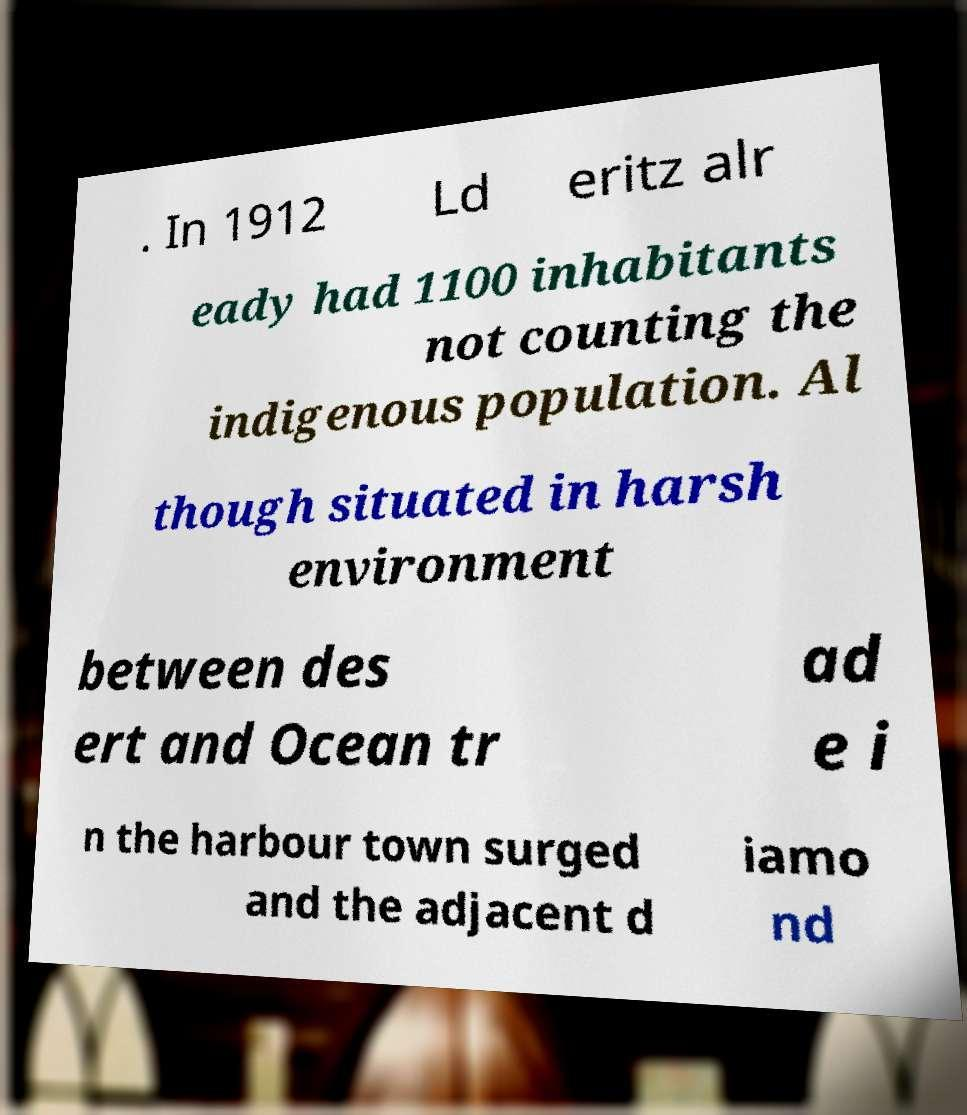Can you accurately transcribe the text from the provided image for me? . In 1912 Ld eritz alr eady had 1100 inhabitants not counting the indigenous population. Al though situated in harsh environment between des ert and Ocean tr ad e i n the harbour town surged and the adjacent d iamo nd 